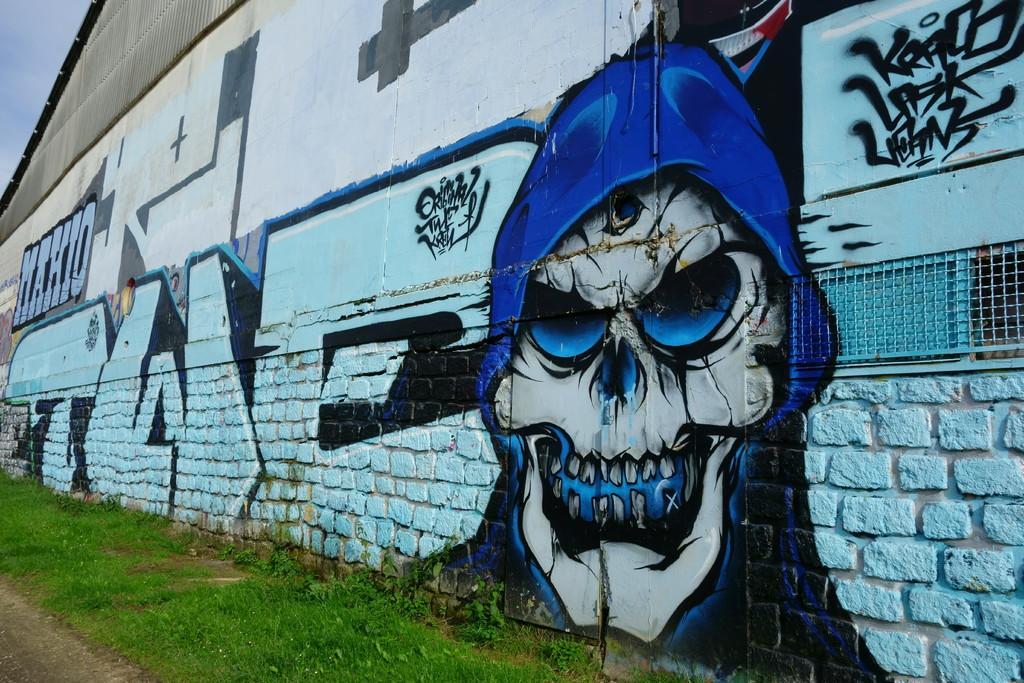Could you give a brief overview of what you see in this image? In this image, we can see some grass and plants. There is a wall in the middle of the image contains an art. There is a sky in the top left of the image. 